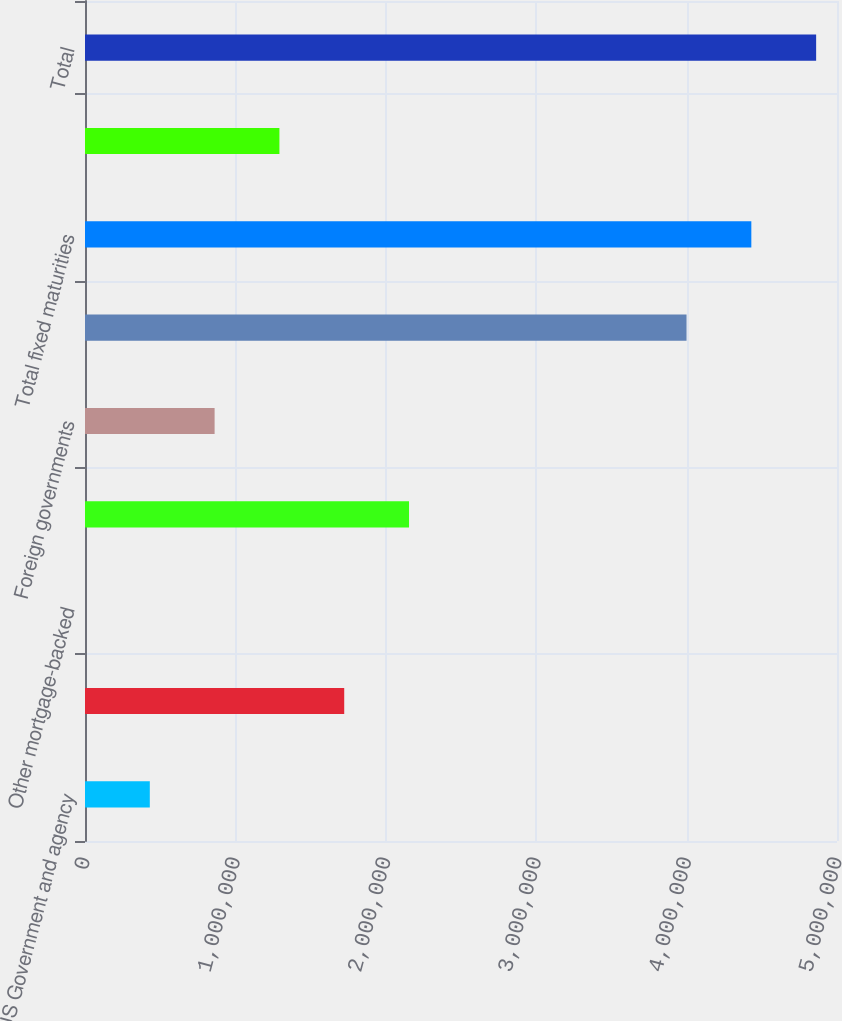<chart> <loc_0><loc_0><loc_500><loc_500><bar_chart><fcel>US Government and agency<fcel>Government-sponsored<fcel>Other mortgage-backed<fcel>States municipalities &<fcel>Foreign governments<fcel>Corporates<fcel>Total fixed maturities<fcel>Equities<fcel>Total<nl><fcel>430883<fcel>1.72353e+06<fcel>1.91<fcel>2.15441e+06<fcel>861765<fcel>3.99954e+06<fcel>4.43042e+06<fcel>1.29265e+06<fcel>4.8613e+06<nl></chart> 